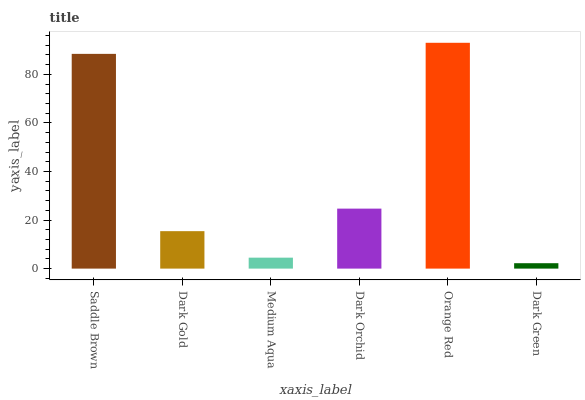Is Dark Green the minimum?
Answer yes or no. Yes. Is Orange Red the maximum?
Answer yes or no. Yes. Is Dark Gold the minimum?
Answer yes or no. No. Is Dark Gold the maximum?
Answer yes or no. No. Is Saddle Brown greater than Dark Gold?
Answer yes or no. Yes. Is Dark Gold less than Saddle Brown?
Answer yes or no. Yes. Is Dark Gold greater than Saddle Brown?
Answer yes or no. No. Is Saddle Brown less than Dark Gold?
Answer yes or no. No. Is Dark Orchid the high median?
Answer yes or no. Yes. Is Dark Gold the low median?
Answer yes or no. Yes. Is Dark Gold the high median?
Answer yes or no. No. Is Orange Red the low median?
Answer yes or no. No. 